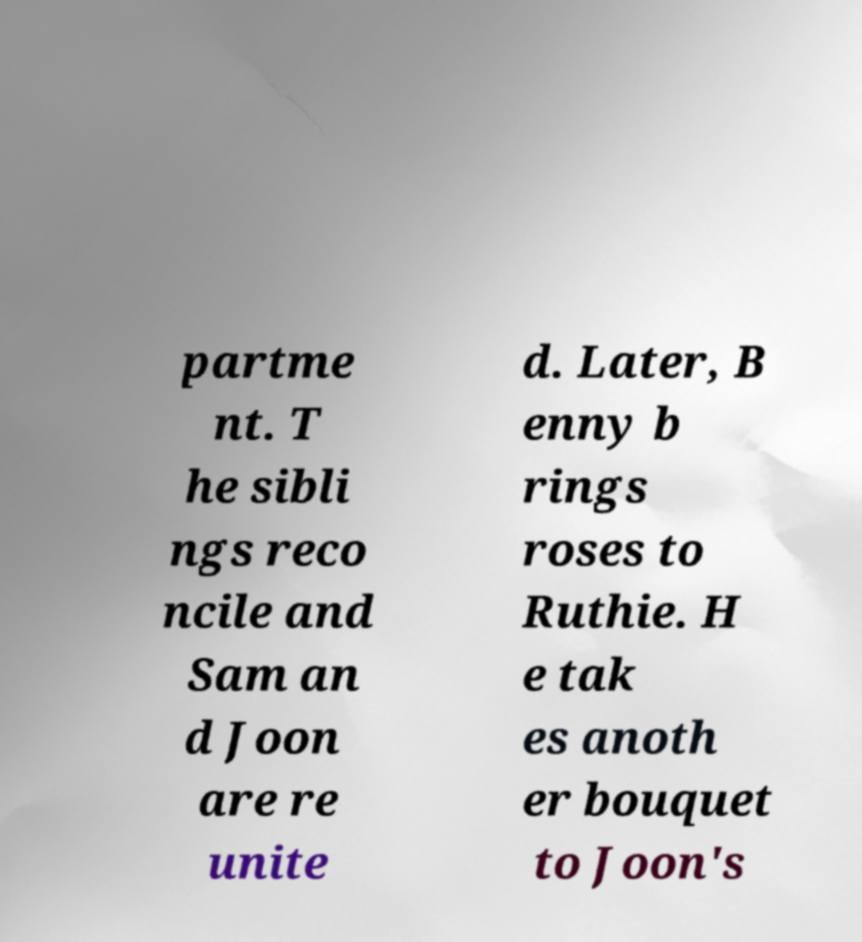Please identify and transcribe the text found in this image. partme nt. T he sibli ngs reco ncile and Sam an d Joon are re unite d. Later, B enny b rings roses to Ruthie. H e tak es anoth er bouquet to Joon's 